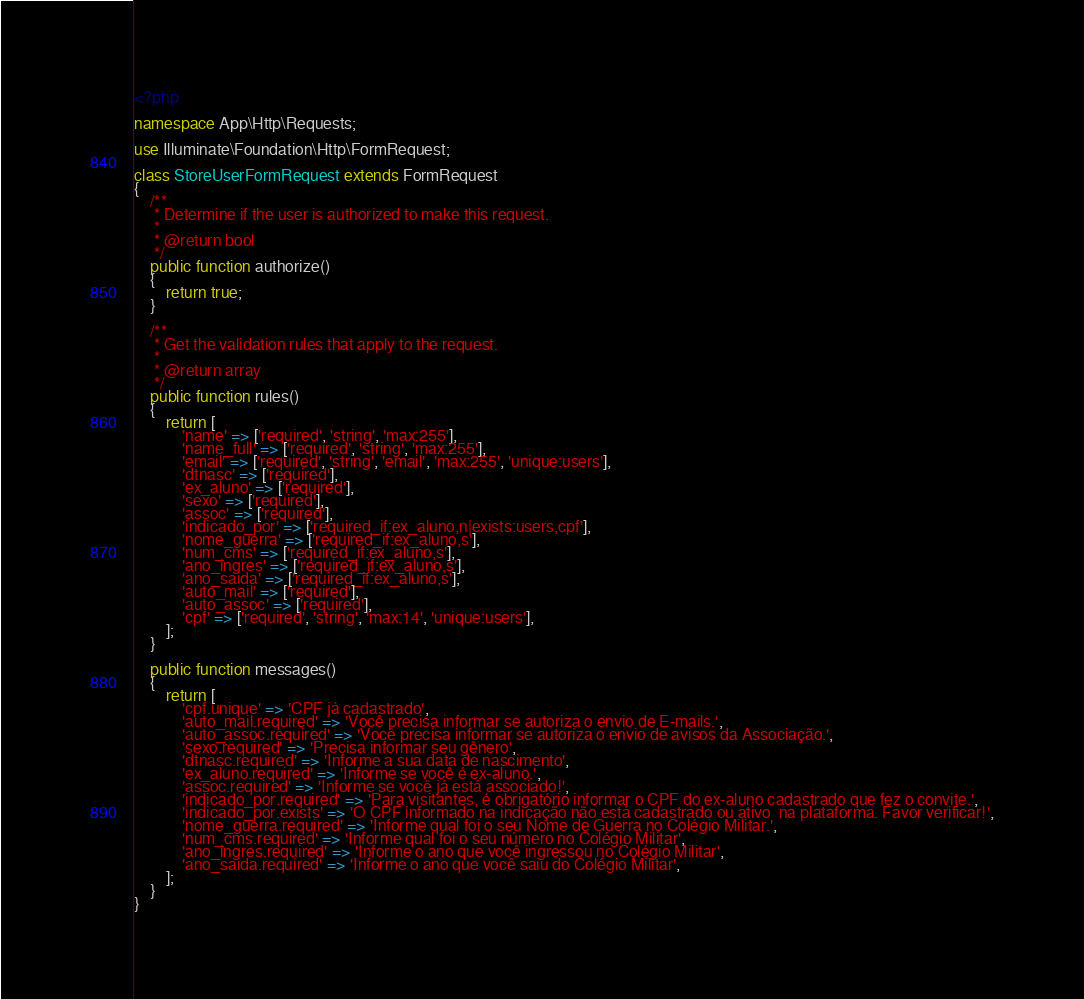Convert code to text. <code><loc_0><loc_0><loc_500><loc_500><_PHP_><?php

namespace App\Http\Requests;

use Illuminate\Foundation\Http\FormRequest;

class StoreUserFormRequest extends FormRequest
{
    /**
     * Determine if the user is authorized to make this request.
     *
     * @return bool
     */
    public function authorize()
    {
        return true;
    }

    /**
     * Get the validation rules that apply to the request.
     *
     * @return array
     */
    public function rules()
    {
        return [
            'name' => ['required', 'string', 'max:255'],
            'name_full' => ['required', 'string', 'max:255'],
            'email' => ['required', 'string', 'email', 'max:255', 'unique:users'],
            'dtnasc' => ['required'],
            'ex_aluno' => ['required'],
            'sexo' => ['required'],
            'assoc' => ['required'],
            'indicado_por' => ['required_if:ex_aluno,n|exists:users,cpf'],
            'nome_guerra' => ['required_if:ex_aluno,s'],
            'num_cms' => ['required_if:ex_aluno,s'],
            'ano_ingres' => ['required_if:ex_aluno,s'],
            'ano_saida' => ['required_if:ex_aluno,s'],
            'auto_mail' => ['required'],
            'auto_assoc' => ['required'],
            'cpf' => ['required', 'string', 'max:14', 'unique:users'],
        ];
    }

    public function messages()
    {
        return [
            'cpf.unique' => 'CPF já cadastrado',
            'auto_mail.required' => 'Você precisa informar se autoriza o envio de E-mails.',
            'auto_assoc.required' => 'Você precisa informar se autoriza o envio de avisos da Associação.',
            'sexo.required' => 'Precisa informar seu gênero',
            'dtnasc.required' => 'Informe a sua data de nascimento',
            'ex_aluno.required' => 'Informe se você é ex-aluno.',
            'assoc.required' => 'Informe se você já está associado!',
            'indicado_por.required' => 'Para visitantes, é obrigatório informar o CPF do ex-aluno cadastrado que fez o convite.',
            'indicado_por.exists' => 'O CPF informado na indicação não está cadastrado ou ativo  na plataforma. Favor verificar!',
            'nome_guerra.required' => 'Informe qual foi o seu Nome de Guerra no Colégio Militar.',
            'num_cms.required' => 'Informe qual foi o seu número no Colégio Militar',
            'ano_ingres.required' => 'Informe o ano que você ingressou no Colégio Militar',
            'ano_saida.required' => 'Informe o ano que você saiu do Colégio Militar',
        ];
    }
}
</code> 